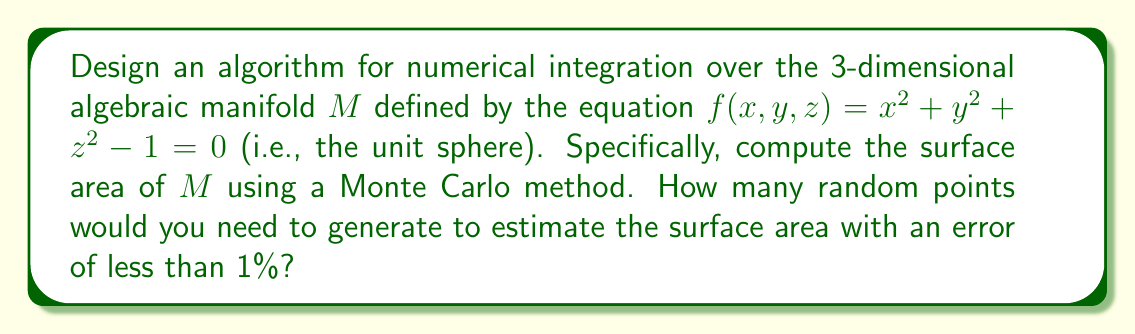Can you answer this question? Let's approach this problem step-by-step, using our understanding of algebraic geometry and numerical methods:

1) First, we need to understand what we're integrating over. The manifold $M$ is the unit sphere, which we can think of as a local ring of functions on a variety, much like how we study schemes in algebraic geometry.

2) The surface area of a unit sphere is known to be $4\pi$. This will be our target value.

3) To use a Monte Carlo method, we'll generate points in a cube that completely contains the sphere. The cube will have side length 2, centered at the origin, so its volume is 8.

4) Our algorithm will work as follows:
   a) Generate a random point $(x,y,z)$ in the cube $[-1,1]^3$.
   b) Check if the point lies on or very close to the sphere by evaluating $|f(x,y,z)| \leq \epsilon$, where $\epsilon$ is a small tolerance.
   c) Repeat this process $N$ times.

5) The estimated surface area will be:

   $$ A_{est} = 8 \cdot \frac{\text{points on sphere}}{\text{total points}} \cdot \frac{3}{2} $$

   The factor $\frac{3}{2}$ comes from the ratio of the cube's surface area (24) to its volume (8).

6) To determine $N$, we can use the Central Limit Theorem. The standard error of our estimate will be approximately:

   $$ \sigma \approx \sqrt{\frac{p(1-p)}{N}} \cdot 8 \cdot \frac{3}{2} $$

   where $p$ is the probability of a point being on the sphere, which is about $\frac{\pi}{6}$.

7) For a 1% error, we want:

   $$ \frac{\sigma}{4\pi} < 0.01 $$

8) Solving this inequality:

   $$ \sqrt{\frac{\pi/6(1-\pi/6)}{N}} \cdot 8 \cdot \frac{3}{2} \cdot \frac{1}{4\pi} < 0.01 $$

   $$ N > \left(\frac{8 \cdot \frac{3}{2} \cdot \frac{1}{4\pi} \cdot \frac{1}{0.01}}\right)^2 \cdot \frac{\pi}{6}\left(1-\frac{\pi}{6}\right) \approx 384,000 $$

Thus, we need approximately 384,000 points to achieve an error of less than 1% with high probability.
Answer: Approximately 384,000 random points are needed to estimate the surface area of the unit sphere with an error of less than 1% using the described Monte Carlo method. 